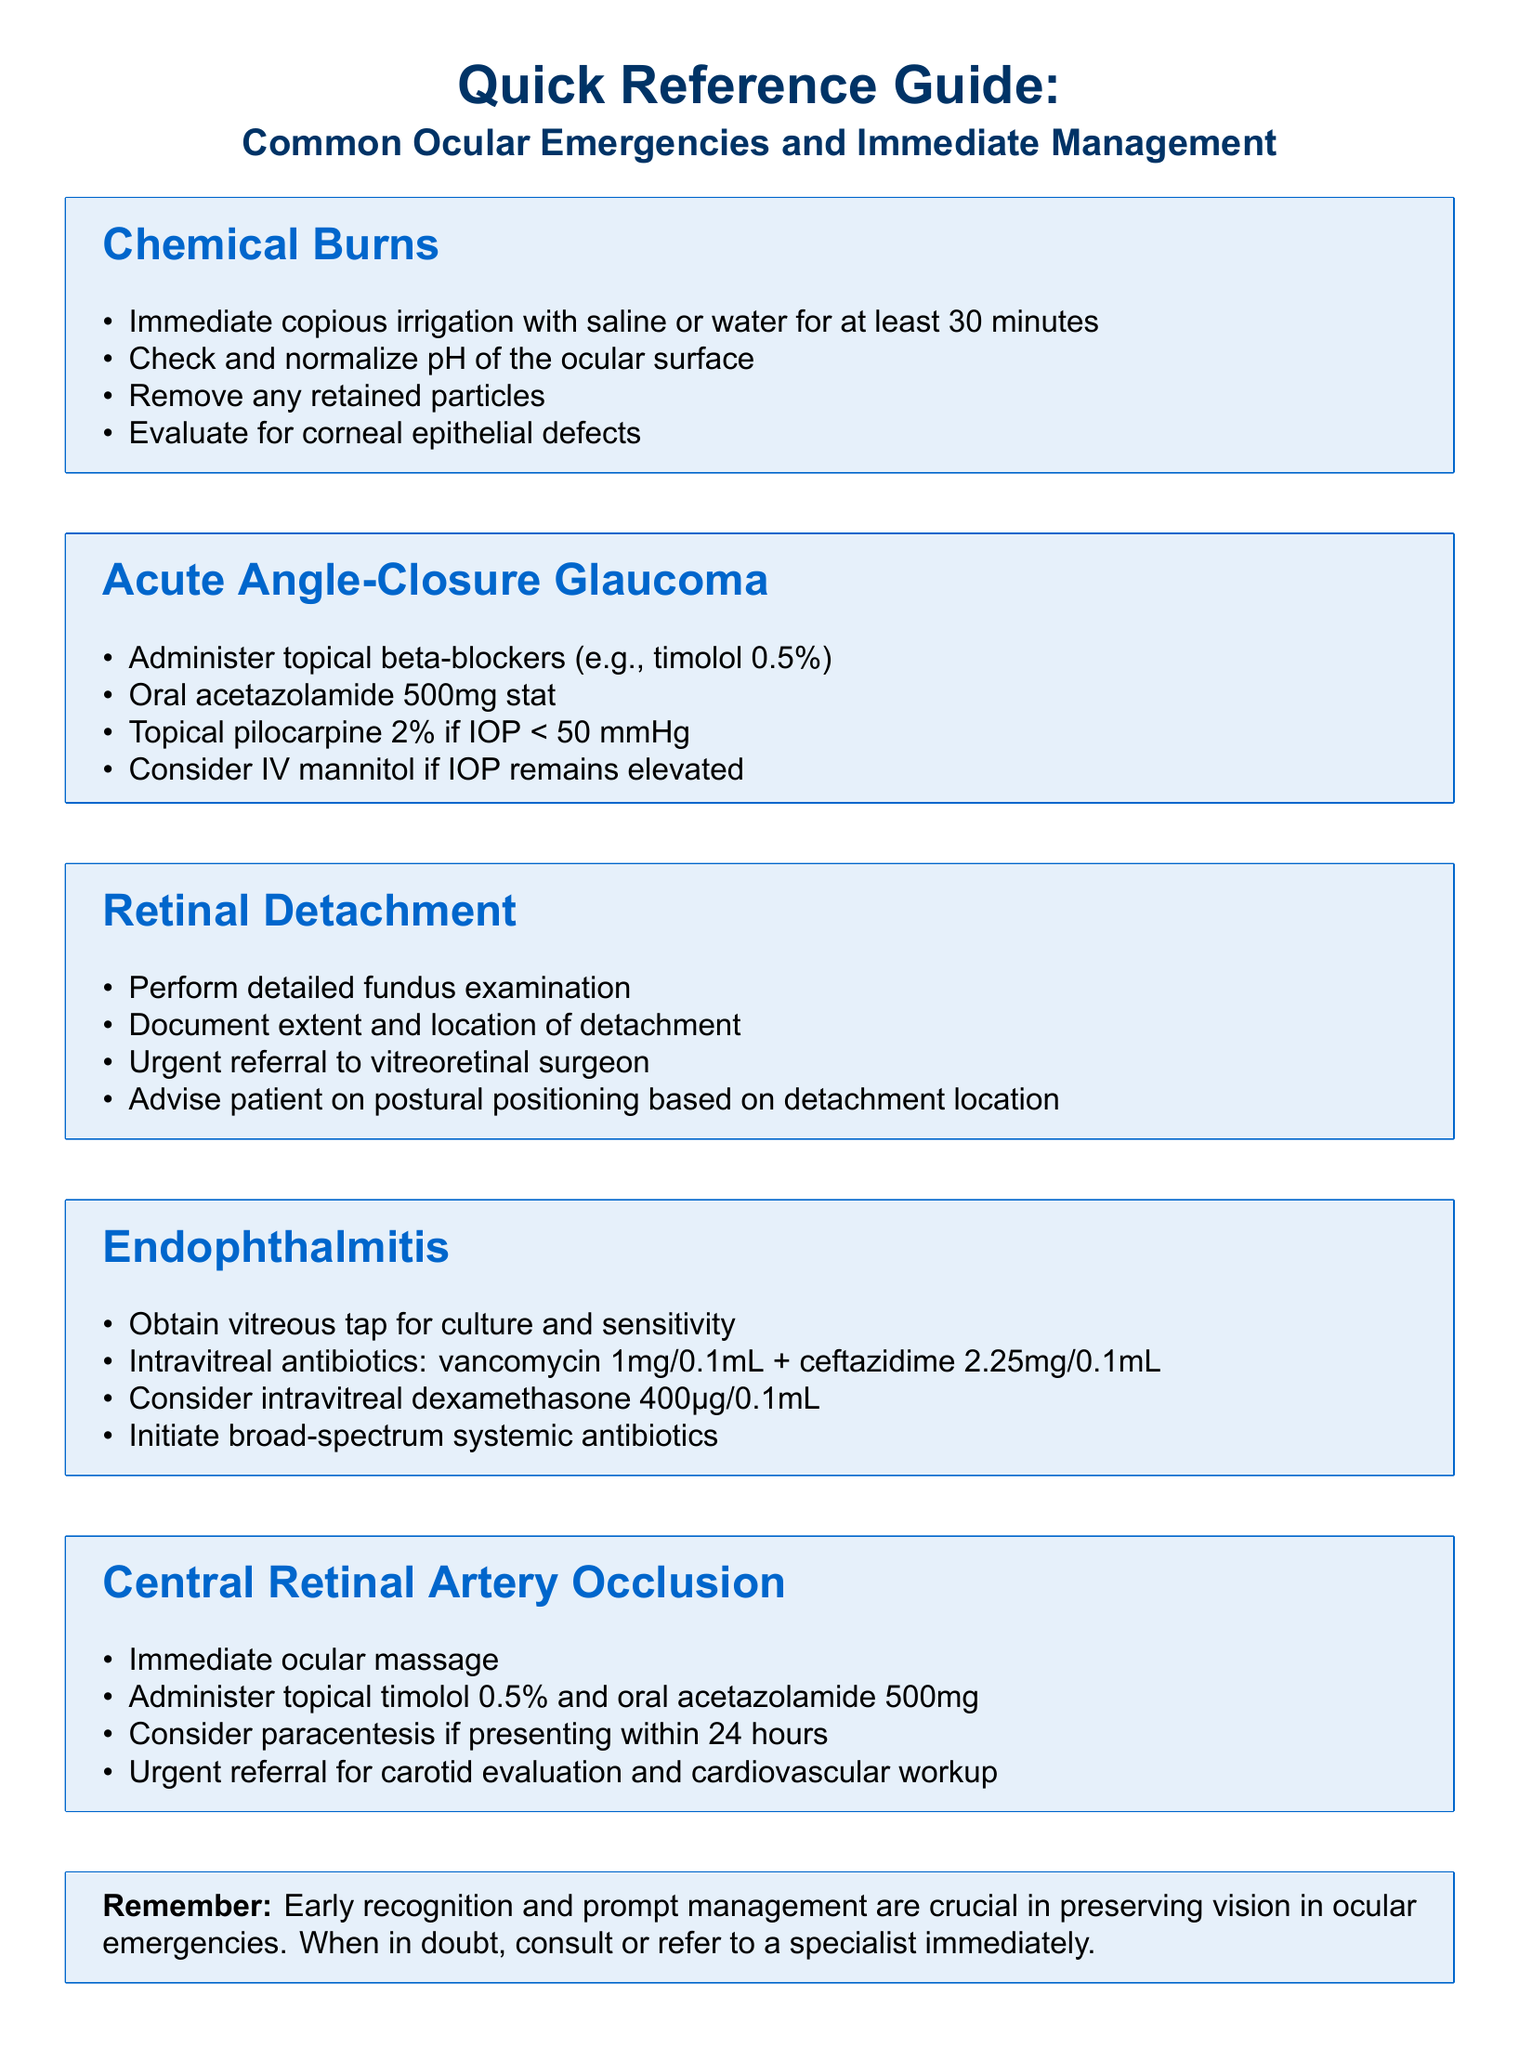What is the first step in managing chemical burns? The first step in managing chemical burns is immediate copious irrigation with saline or water for at least 30 minutes.
Answer: Immediate copious irrigation with saline or water for at least 30 minutes What medication should be administered stat for acute angle-closure glaucoma? The medication that should be administered stat for acute angle-closure glaucoma is oral acetazolamide 500mg.
Answer: Oral acetazolamide 500mg stat What is a crucial step in the management of retinal detachment? A crucial step in the management of retinal detachment is urgent referral to a vitreoretinal surgeon.
Answer: Urgent referral to vitreoretinal surgeon Which antibiotics are recommended for endophthalmitis? The recommended antibiotics for endophthalmitis are vancomycin and ceftazidime.
Answer: Vancomycin and ceftazidime What is indicated for central retinal artery occlusion if presenting within 24 hours? Paracentesis is indicated for central retinal artery occlusion if presenting within 24 hours.
Answer: Paracentesis What should be done to evaluate the extent of retinal detachment? To evaluate the extent of retinal detachment, a detailed fundus examination should be performed.
Answer: Perform detailed fundus examination What common action should be taken for a chemical burn before other measures? Copious irrigation is a common action to take for a chemical burn before other measures.
Answer: Copious irrigation What should be checked after irrigation in cases of chemical burn? The pH of the ocular surface should be checked and normalized after irrigation in cases of chemical burn.
Answer: Check and normalize pH of the ocular surface 